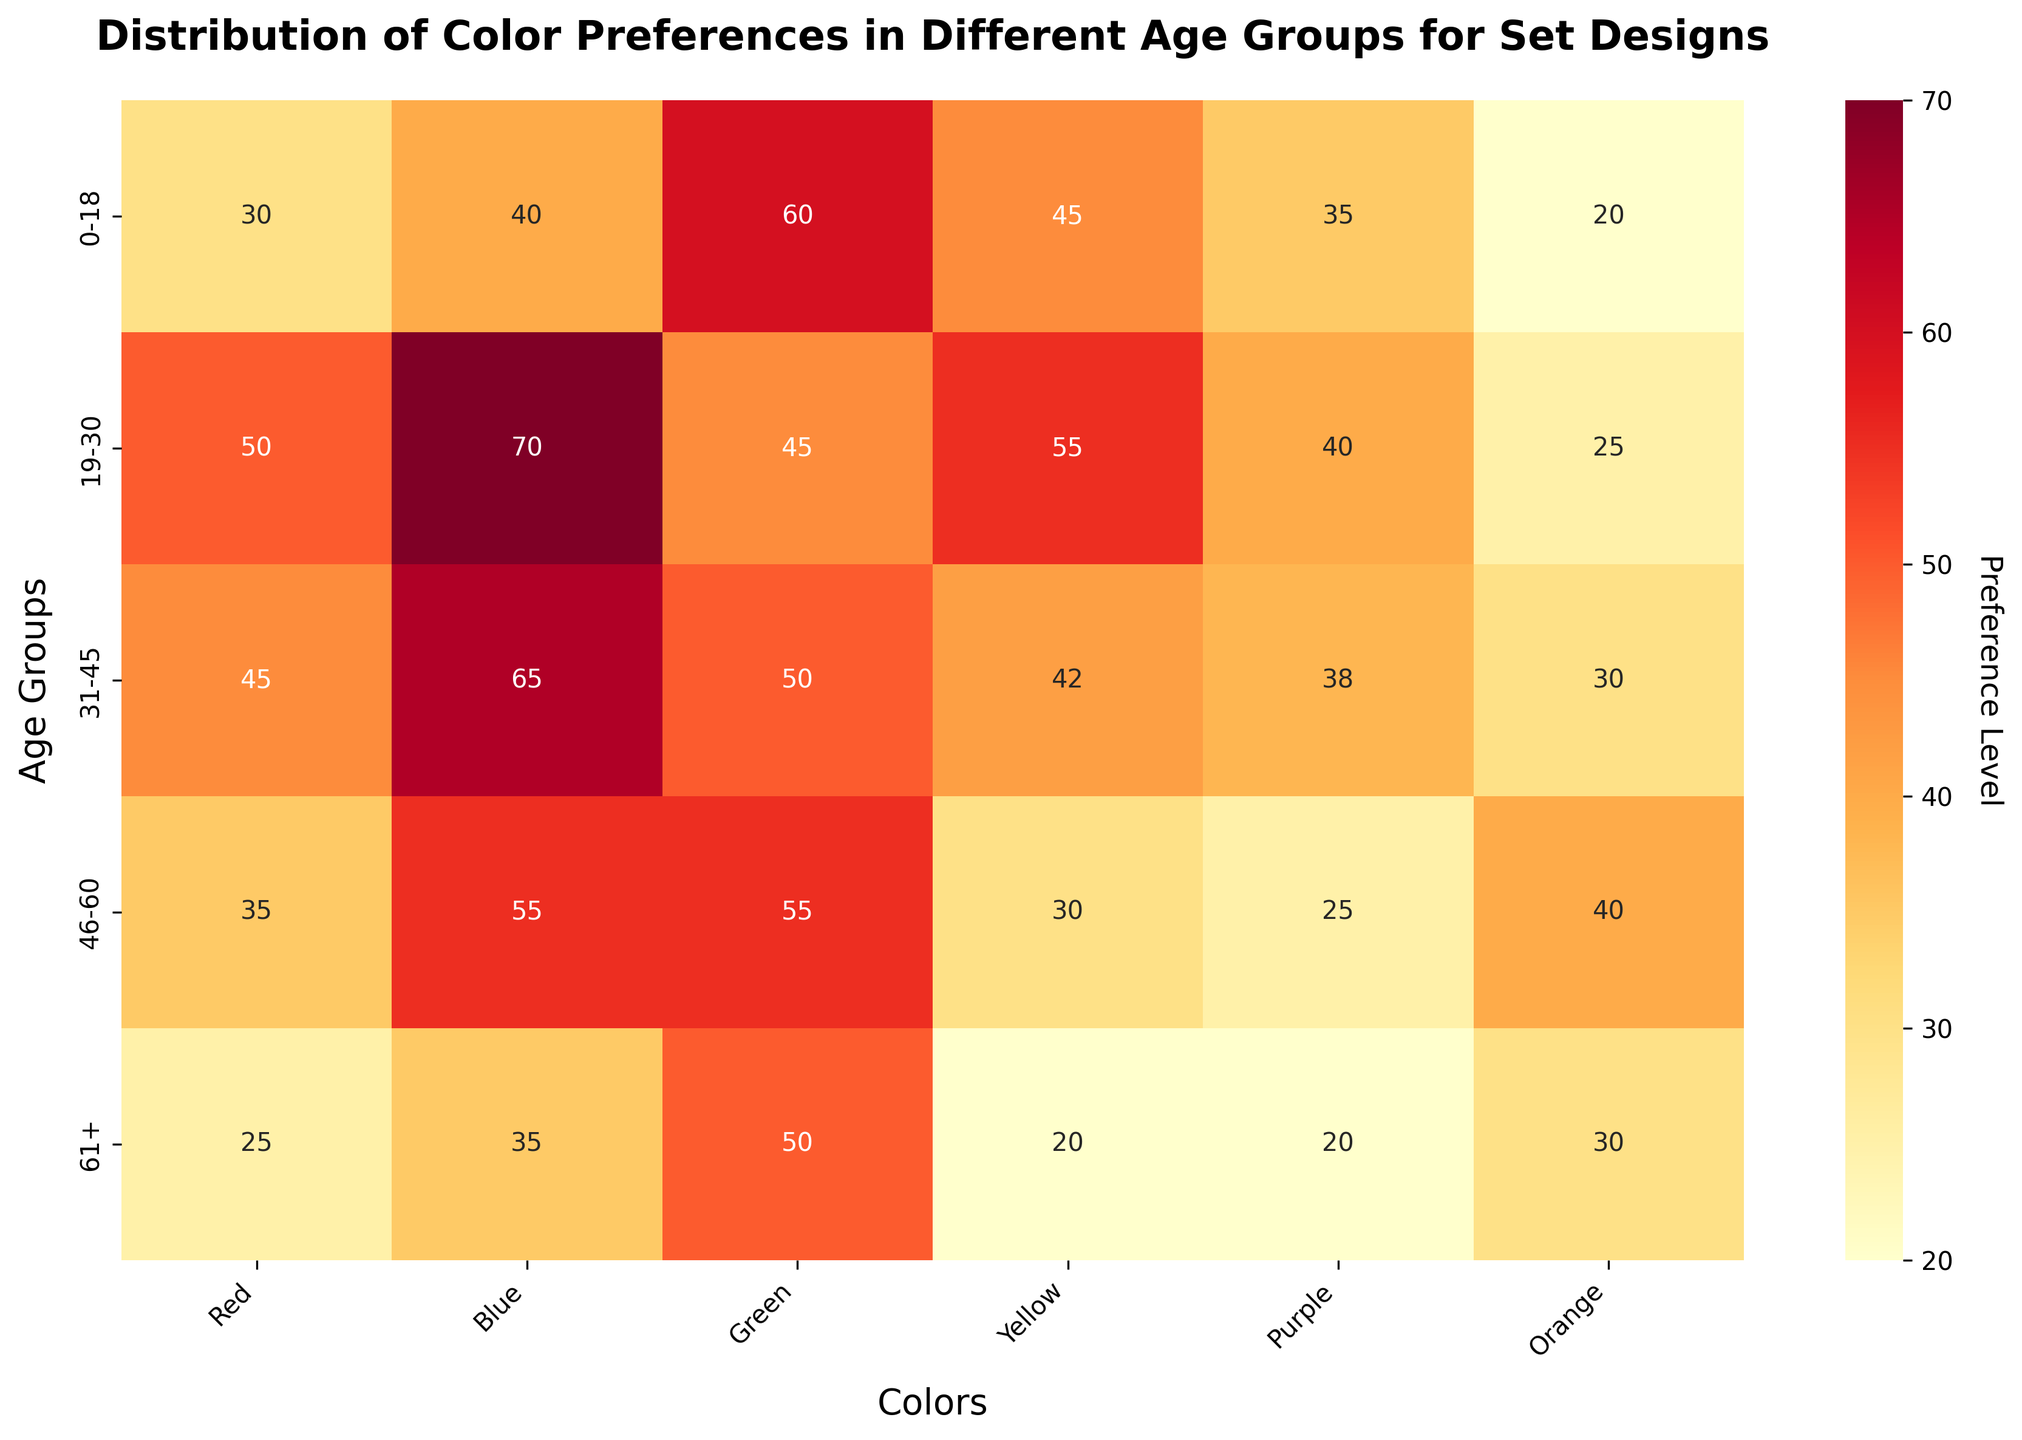What's the title of the heatmap? The title is displayed above the heatmap and is written in bold font.
Answer: Distribution of Color Preferences in Different Age Groups for Set Designs What does the color yellow represent in the heatmap? The color yellow in the heatmap represents higher preference levels for colors based on the color gradient scale used (YlOrRd).
Answer: Higher preference levels Which age group has the highest preference for Blue? To find the highest value in the Blue column, look for the largest number in that column.
Answer: 19-30 Compare the preference levels for Green between the age groups 0-18 and 61+. Find the values for Green in both age groups and compare them. 0-18 has 60 and 61+ has 50.
Answer: 0-18 is higher What is the sum of preferences for Red and Orange in the age group 31-45? Locate the values for Red (45) and Orange (30) in the age group 31-45 and add them together. 45 + 30 = 75.
Answer: 75 Which age group has the lowest preference for Yellow? Identify the smallest number in the Yellow column across all age groups.
Answer: 61+ What is the average preference for Purple across all age groups? Add all the values for Purple and divide by the number of age groups. (35+40+38+25+20) / 5 = 31.6
Answer: 31.6 How does the preference for Orange change from the 0-18 age group to the 61+ age group? Subtract the Orange preference value for 61+ (30) from the value for 0-18 (20). 30 - 20 = 10.
Answer: Increases by 10 Which color has the most consistent preference levels across all age groups? Compare the variance of the preference values for each color. Blue has values 40, 70, 65, 55, 35 which seem more evenly spread.
Answer: Blue 